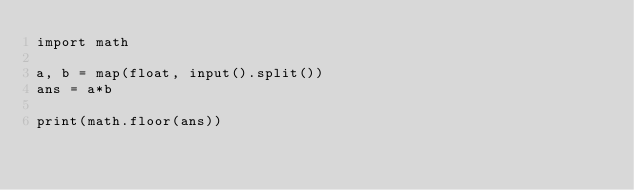<code> <loc_0><loc_0><loc_500><loc_500><_Python_>import math

a, b = map(float, input().split())
ans = a*b

print(math.floor(ans))</code> 